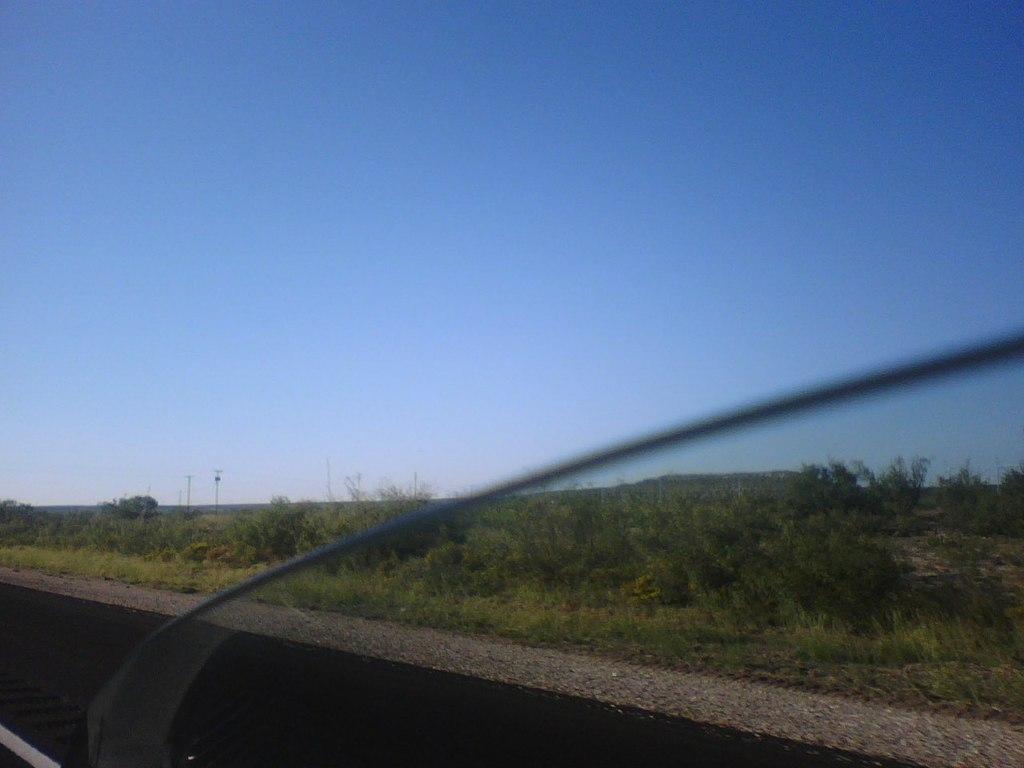In one or two sentences, can you explain what this image depicts? In this image we can see some plants, trees and poles, in the background we can see the sky. 